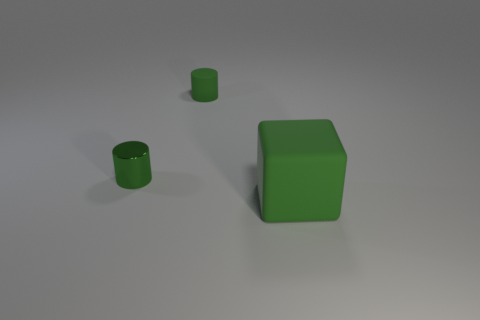Subtract all cubes. How many objects are left? 2 Subtract all green cubes. How many gray cylinders are left? 0 Add 3 tiny shiny things. How many objects exist? 6 Subtract all purple cylinders. Subtract all purple blocks. How many cylinders are left? 2 Subtract all tiny blue cubes. Subtract all big green rubber cubes. How many objects are left? 2 Add 2 tiny green rubber cylinders. How many tiny green rubber cylinders are left? 3 Add 2 shiny objects. How many shiny objects exist? 3 Subtract 0 red balls. How many objects are left? 3 